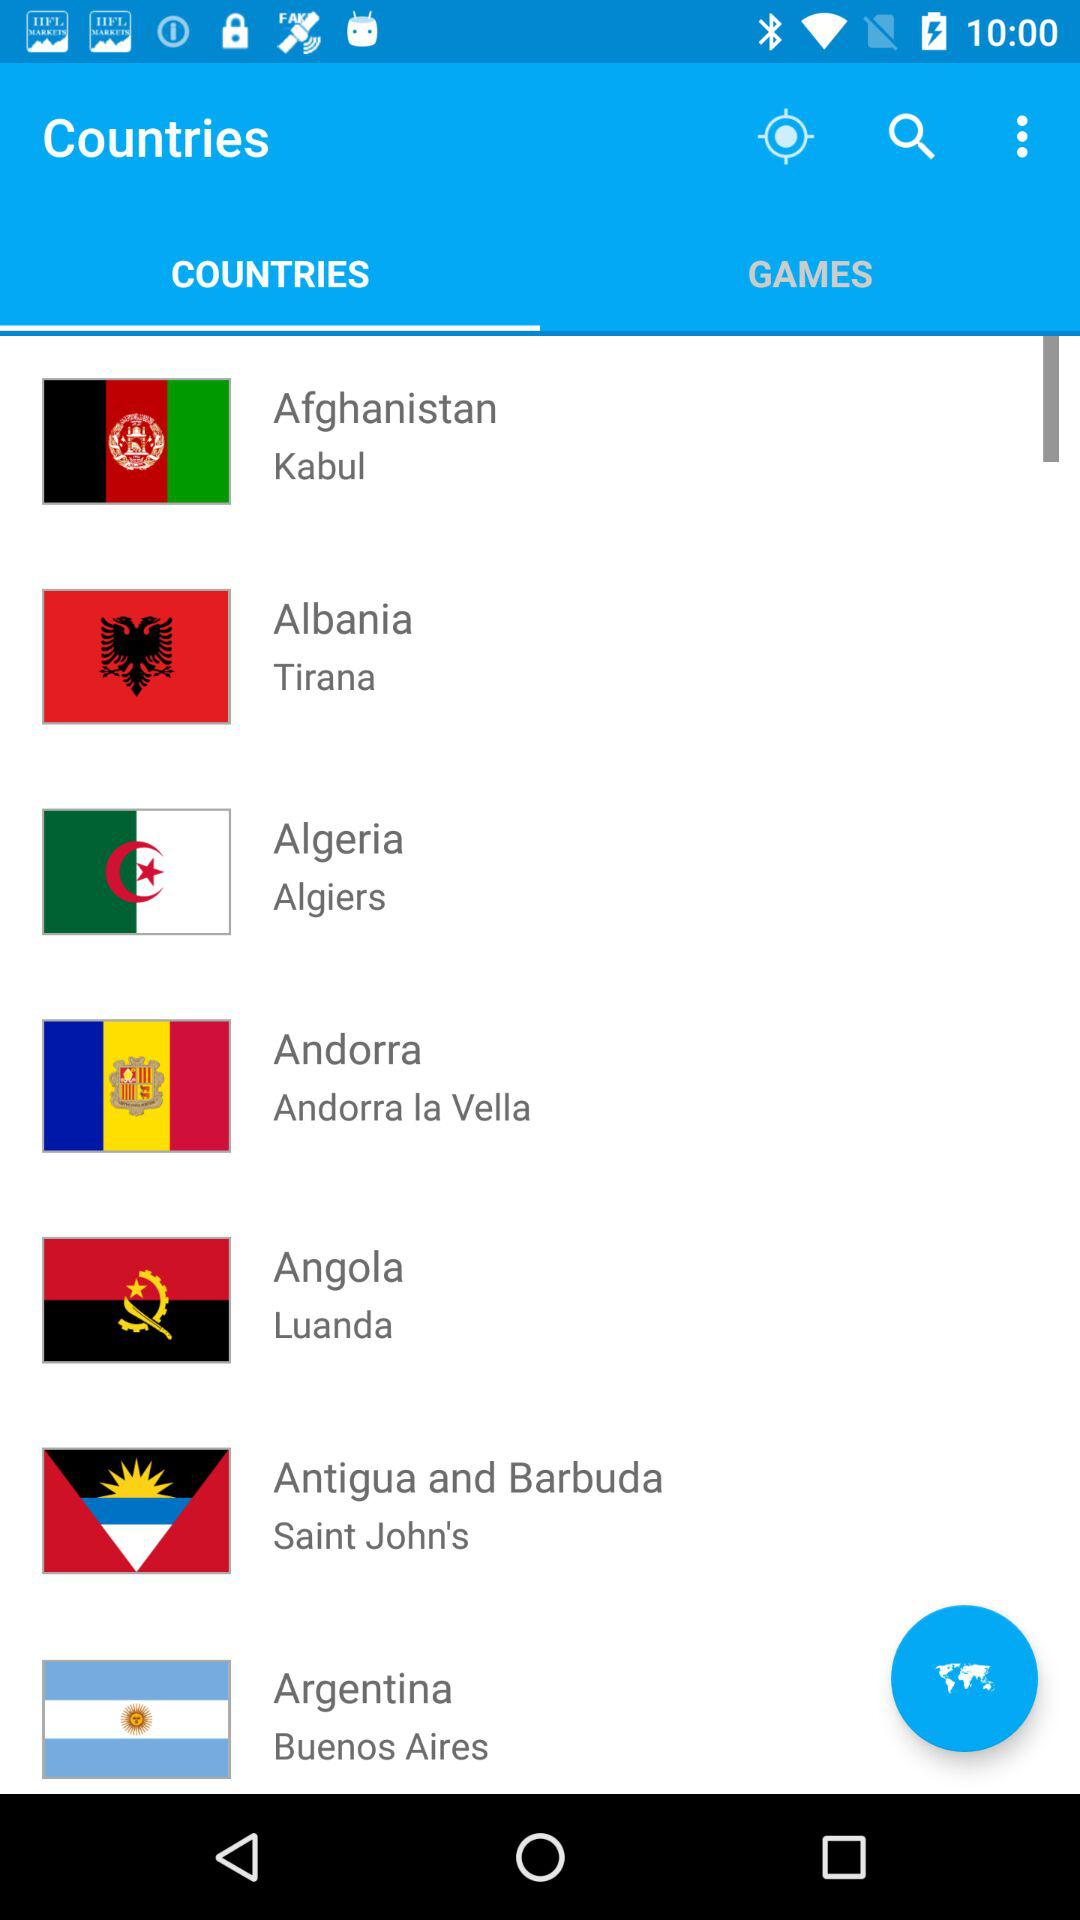What's the capital of Algeria? The capital of Algeria is Algiers. 